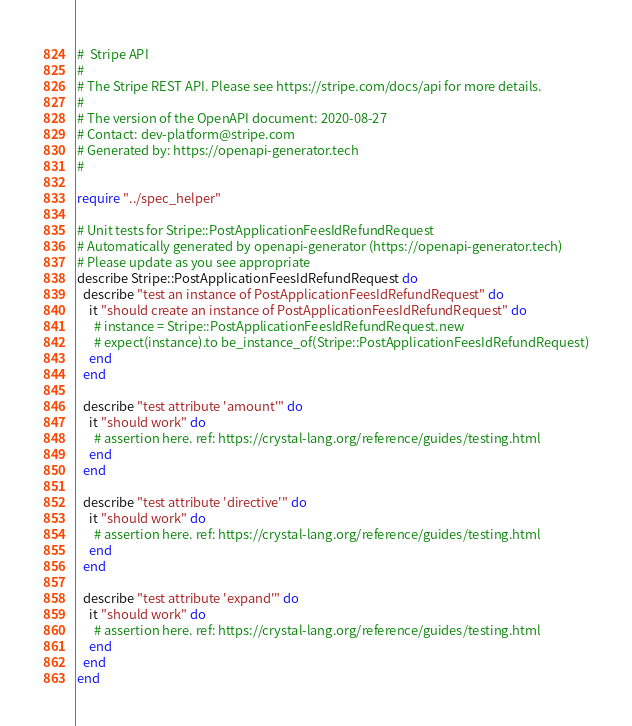Convert code to text. <code><loc_0><loc_0><loc_500><loc_500><_Crystal_>#  Stripe API
#
# The Stripe REST API. Please see https://stripe.com/docs/api for more details.
#
# The version of the OpenAPI document: 2020-08-27
# Contact: dev-platform@stripe.com
# Generated by: https://openapi-generator.tech
#

require "../spec_helper"

# Unit tests for Stripe::PostApplicationFeesIdRefundRequest
# Automatically generated by openapi-generator (https://openapi-generator.tech)
# Please update as you see appropriate
describe Stripe::PostApplicationFeesIdRefundRequest do
  describe "test an instance of PostApplicationFeesIdRefundRequest" do
    it "should create an instance of PostApplicationFeesIdRefundRequest" do
      # instance = Stripe::PostApplicationFeesIdRefundRequest.new
      # expect(instance).to be_instance_of(Stripe::PostApplicationFeesIdRefundRequest)
    end
  end

  describe "test attribute 'amount'" do
    it "should work" do
      # assertion here. ref: https://crystal-lang.org/reference/guides/testing.html
    end
  end

  describe "test attribute 'directive'" do
    it "should work" do
      # assertion here. ref: https://crystal-lang.org/reference/guides/testing.html
    end
  end

  describe "test attribute 'expand'" do
    it "should work" do
      # assertion here. ref: https://crystal-lang.org/reference/guides/testing.html
    end
  end
end
</code> 